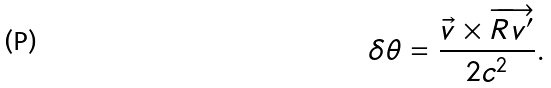<formula> <loc_0><loc_0><loc_500><loc_500>\delta \theta = \frac { \vec { v } \times \overrightarrow { R v ^ { \prime } } } { 2 c ^ { 2 } } .</formula> 